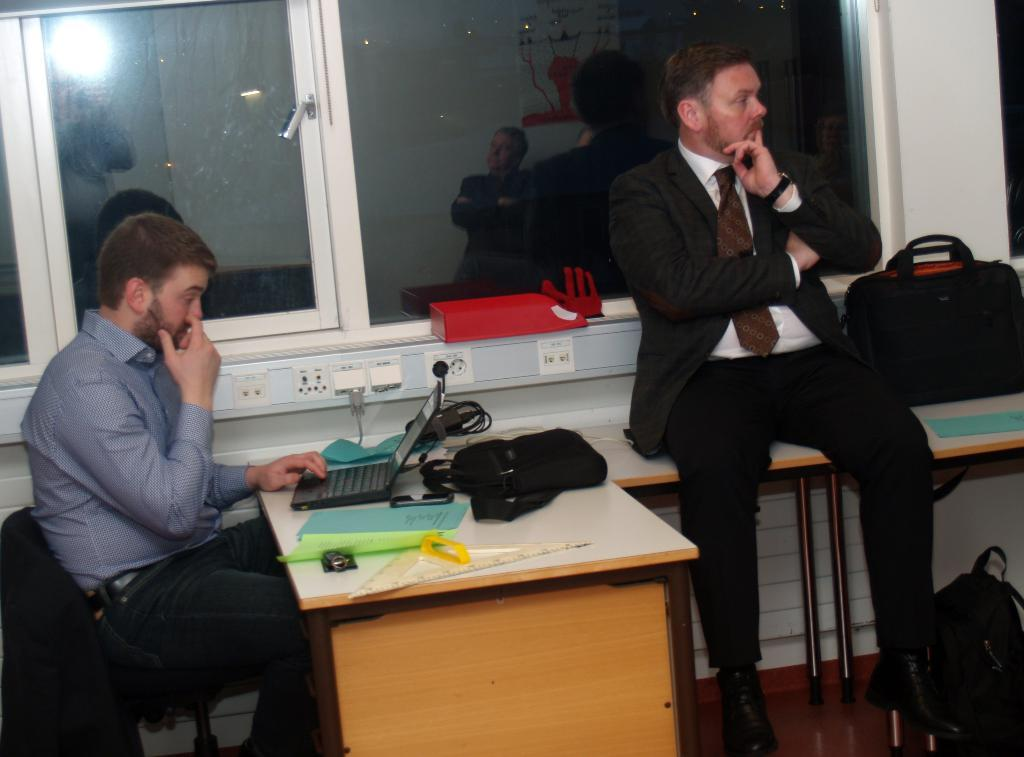What is the man in the image doing? The man is sitting in a chair and working on a laptop. What can be seen on the table in front of the man? There are big files and other accessories on the table. Is there anyone else in the image? Yes, there is another man sitting on a table beside the first man. What is the second man holding or using? The second man has a bag on the table. What type of cast is the man wearing on his leg in the image? There is no cast visible on the man's leg in the image. What rule does the queen enforce in the image? There is no queen or rule mentioned in the image. 